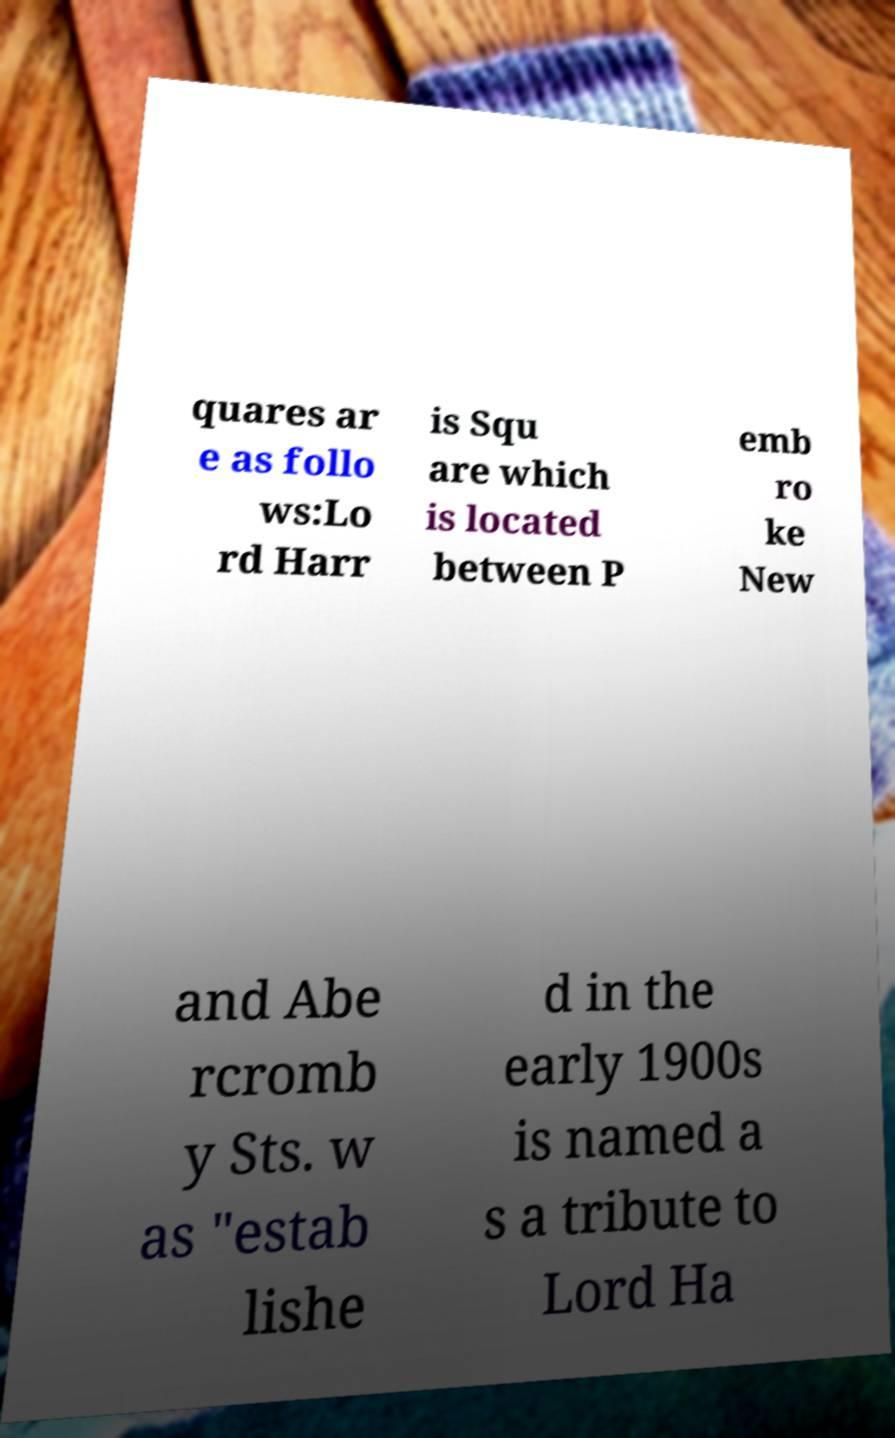Please read and relay the text visible in this image. What does it say? quares ar e as follo ws:Lo rd Harr is Squ are which is located between P emb ro ke New and Abe rcromb y Sts. w as "estab lishe d in the early 1900s is named a s a tribute to Lord Ha 